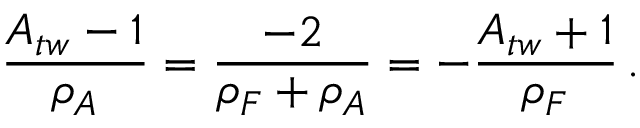<formula> <loc_0><loc_0><loc_500><loc_500>\frac { A _ { t w } - 1 } { \rho _ { A } } = \frac { - 2 } { \rho _ { F } + \rho _ { A } } = - \frac { A _ { t w } + 1 } { \rho _ { F } } \, .</formula> 